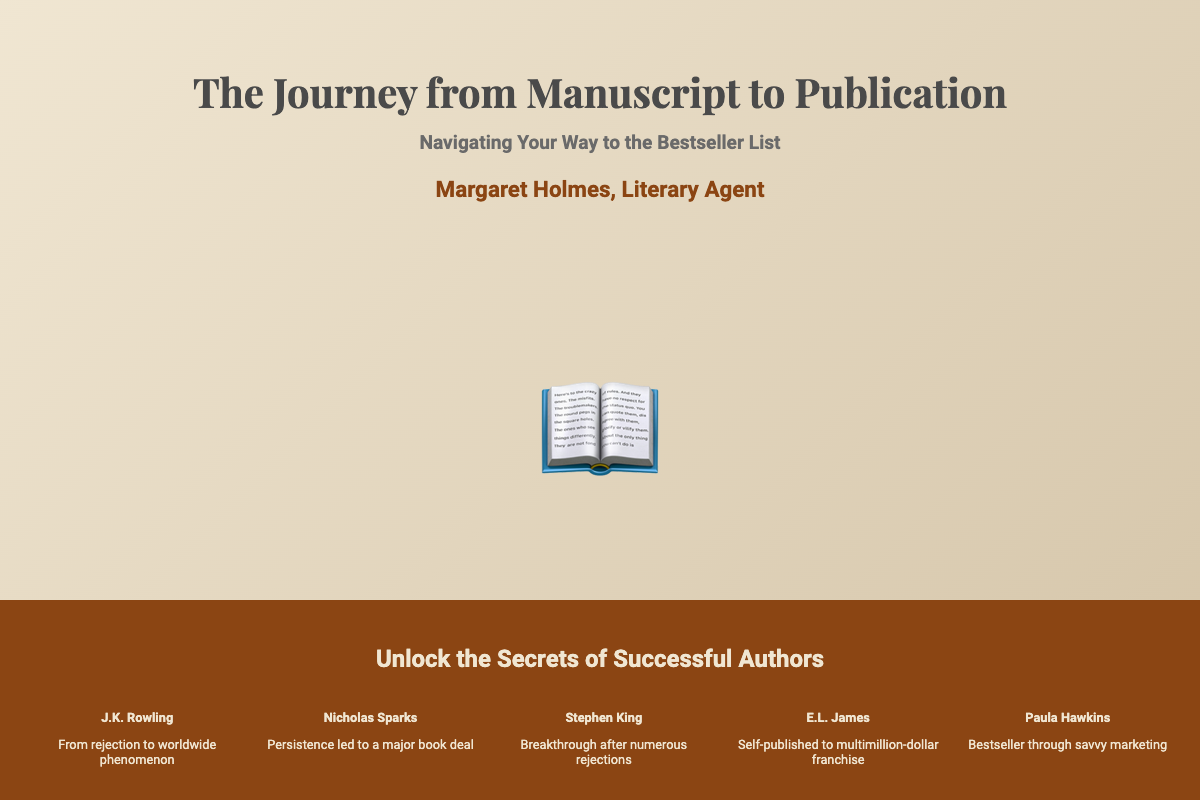What is the title of the book? The title is prominently displayed at the top of the document.
Answer: The Journey from Manuscript to Publication Who is the author of the book? The author's name is mentioned below the title.
Answer: Margaret Holmes What is the subtitle of the book? The subtitle provides a theme and is found below the title.
Answer: Navigating Your Way to the Bestseller List What type of stories are included in the book? The success stories are aimed at inspiring aspiring authors.
Answer: Success stories How many success stories are featured on the cover? The cover indicates the number of authors whose stories are shared.
Answer: Five Which author went from rejection to a worldwide phenomenon? This detail highlights one of the featured success stories.
Answer: J.K. Rowling What color is the bottom section of the book cover? The bottom section color is mentioned as part of the design description.
Answer: Dark brown What is the tagline of the book? The tagline is a succinct phrase that sums up the book's essence and is found at the bottom section.
Answer: Unlock the Secrets of Successful Authors What symbol is used in the middle section of the cover? The icon displayed in the middle section is part of the visual representation of the book.
Answer: A book What is the main theme of the book? The overarching theme relates to the publishing journey for new authors.
Answer: Journey to publication 